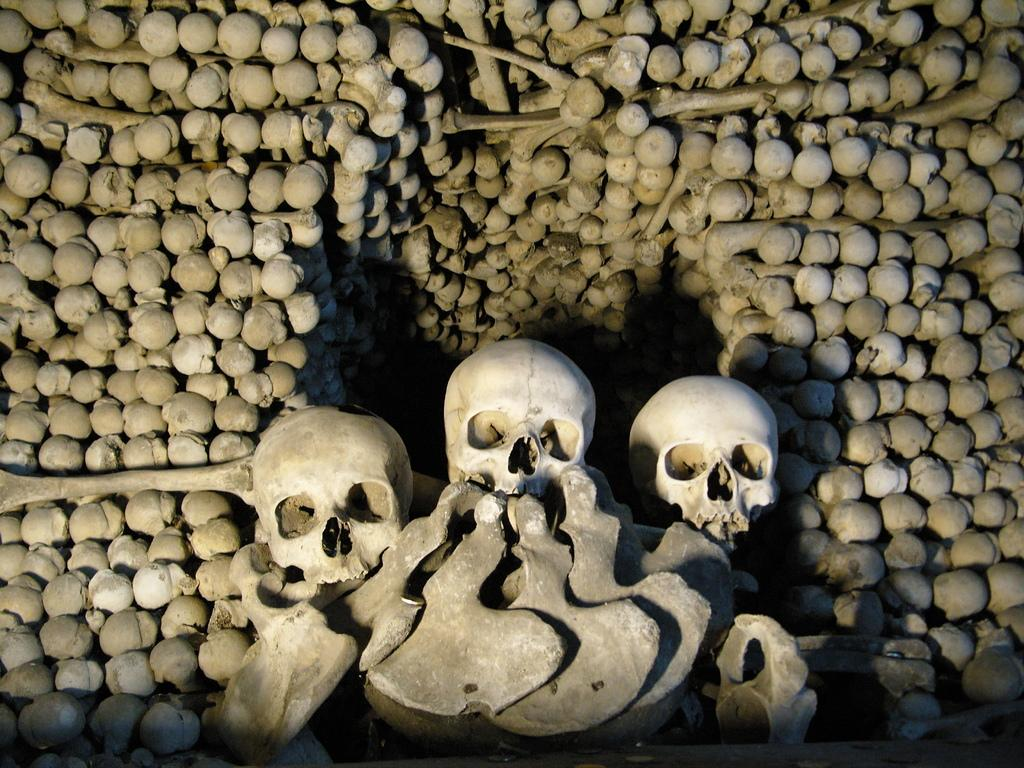What is the main subject of the image? The main subject of the image is three skulls. Are there any other related objects visible in the image? Yes, there are bones visible in the image. What type of laborer can be seen running in the image? There are no laborers or any running figures present in the image; it features three skulls and bones. What achievements can be attributed to the skulls in the image? The skulls in the image are not living beings and therefore cannot have achievements. 